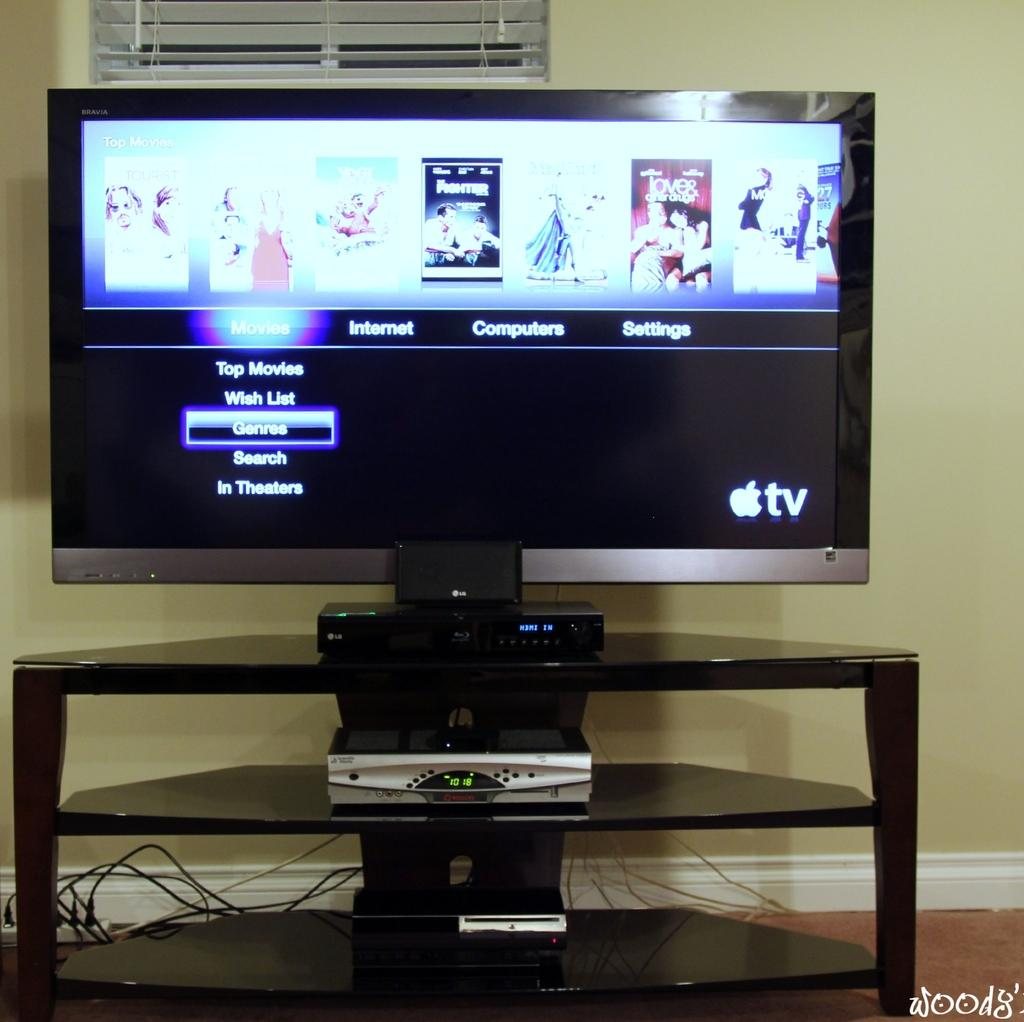Provide a one-sentence caption for the provided image. The visual menu of an Apple tv has the cursor on genres. 